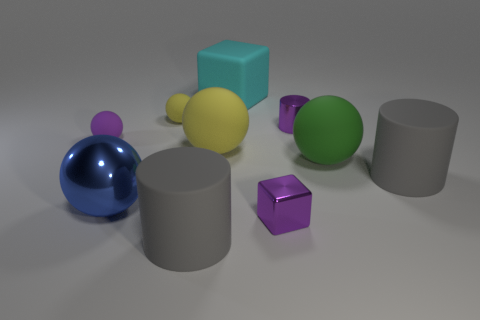What is the material of the small purple cylinder?
Your answer should be very brief. Metal. How many other things are the same size as the green rubber ball?
Provide a short and direct response. 5. There is a gray rubber cylinder right of the green object; how big is it?
Ensure brevity in your answer.  Large. What is the material of the large cyan block that is right of the rubber cylinder that is to the left of the big thing that is behind the tiny purple metal cylinder?
Your response must be concise. Rubber. Do the big green rubber object and the big yellow rubber thing have the same shape?
Offer a very short reply. Yes. What number of metal objects are either tiny blue blocks or small balls?
Make the answer very short. 0. How many yellow things are there?
Keep it short and to the point. 2. There is a metallic thing that is the same size as the purple cylinder; what is its color?
Your response must be concise. Purple. Does the cyan thing have the same size as the green rubber ball?
Your answer should be compact. Yes. What is the shape of the small matte object that is the same color as the tiny metallic block?
Give a very brief answer. Sphere. 